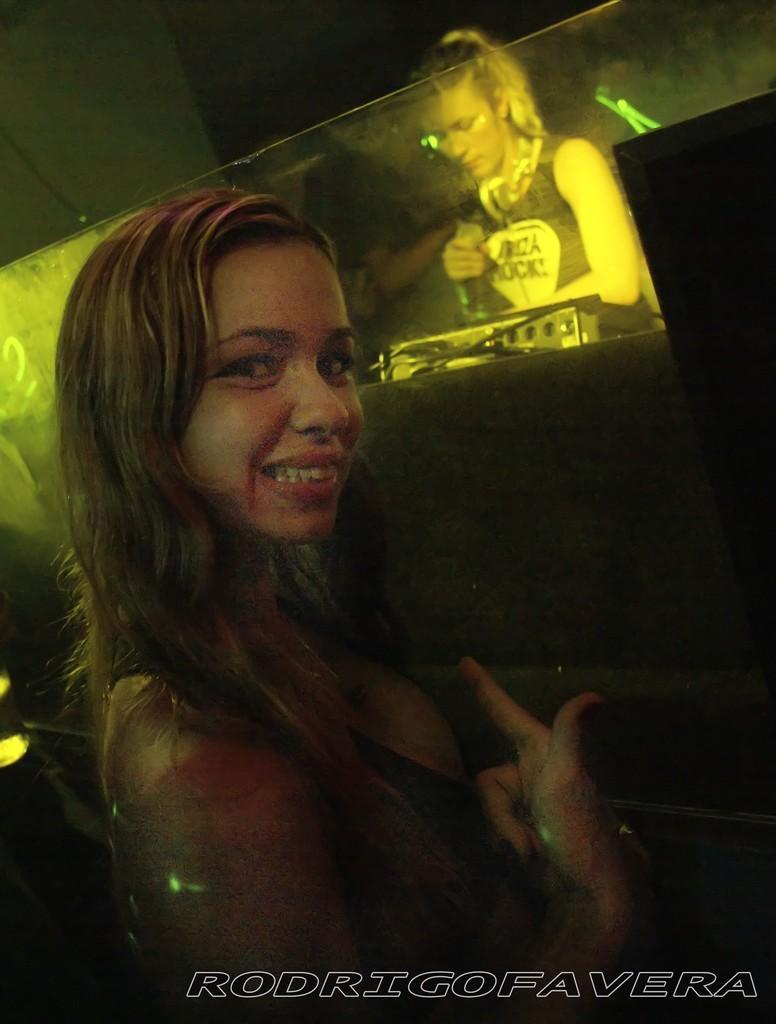Could you give a brief overview of what you see in this image? In the picture we can see a woman standing and turning her head and smiling and behind her we can see a woman standing behind a glass wall. 